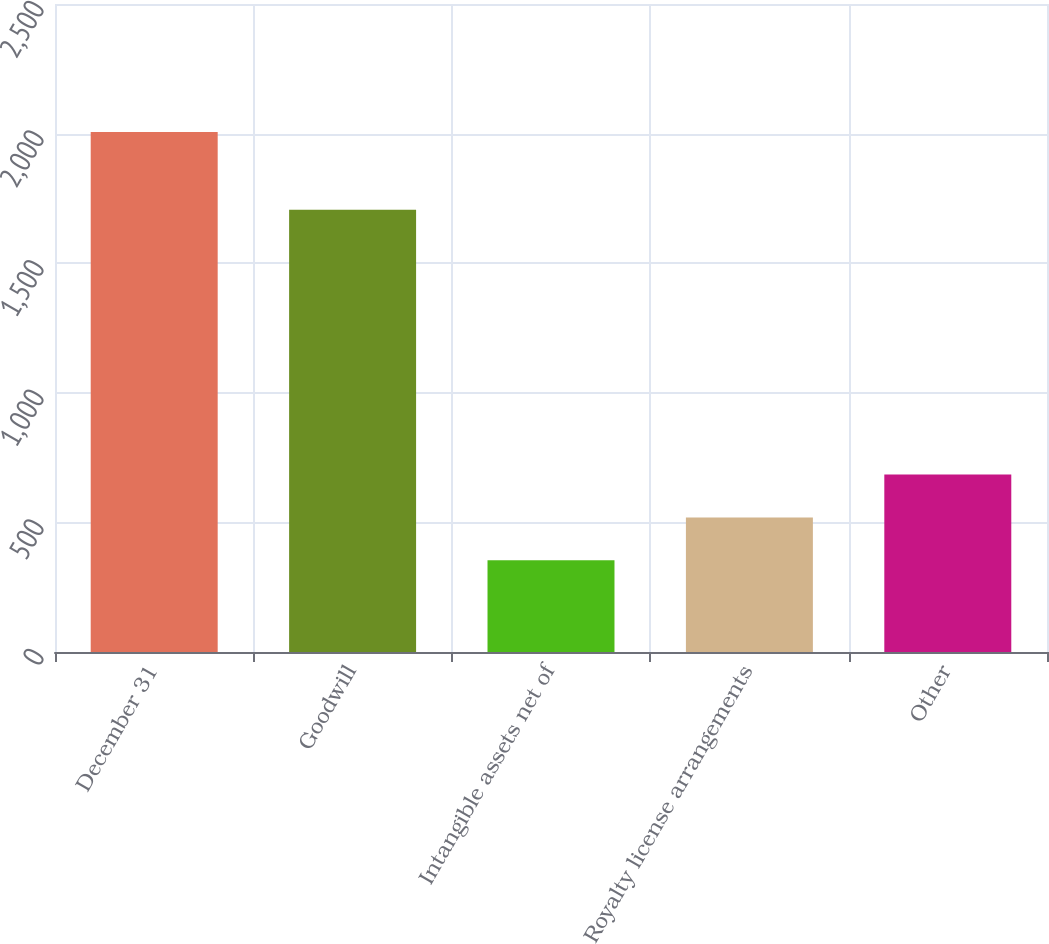Convert chart. <chart><loc_0><loc_0><loc_500><loc_500><bar_chart><fcel>December 31<fcel>Goodwill<fcel>Intangible assets net of<fcel>Royalty license arrangements<fcel>Other<nl><fcel>2006<fcel>1706<fcel>354<fcel>519.2<fcel>684.4<nl></chart> 